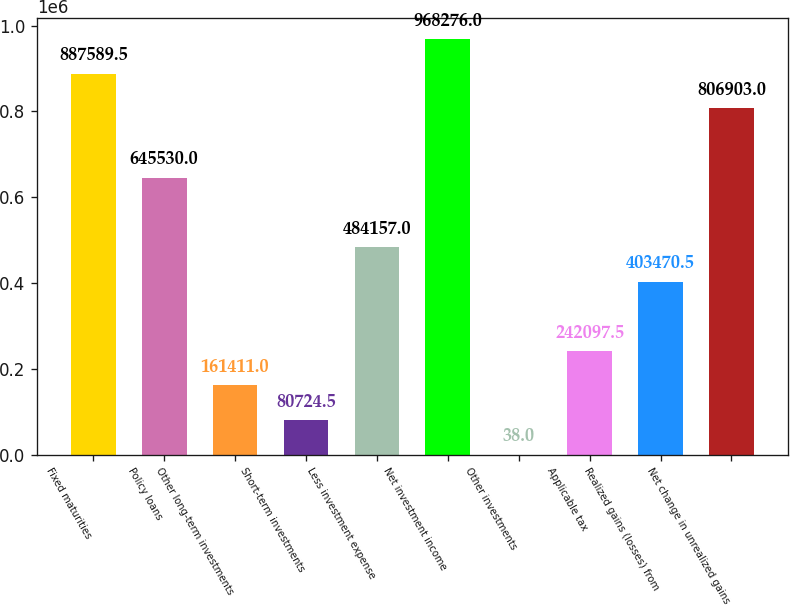Convert chart. <chart><loc_0><loc_0><loc_500><loc_500><bar_chart><fcel>Fixed maturities<fcel>Policy loans<fcel>Other long-term investments<fcel>Short-term investments<fcel>Less investment expense<fcel>Net investment income<fcel>Other investments<fcel>Applicable tax<fcel>Realized gains (losses) from<fcel>Net change in unrealized gains<nl><fcel>887590<fcel>645530<fcel>161411<fcel>80724.5<fcel>484157<fcel>968276<fcel>38<fcel>242098<fcel>403470<fcel>806903<nl></chart> 